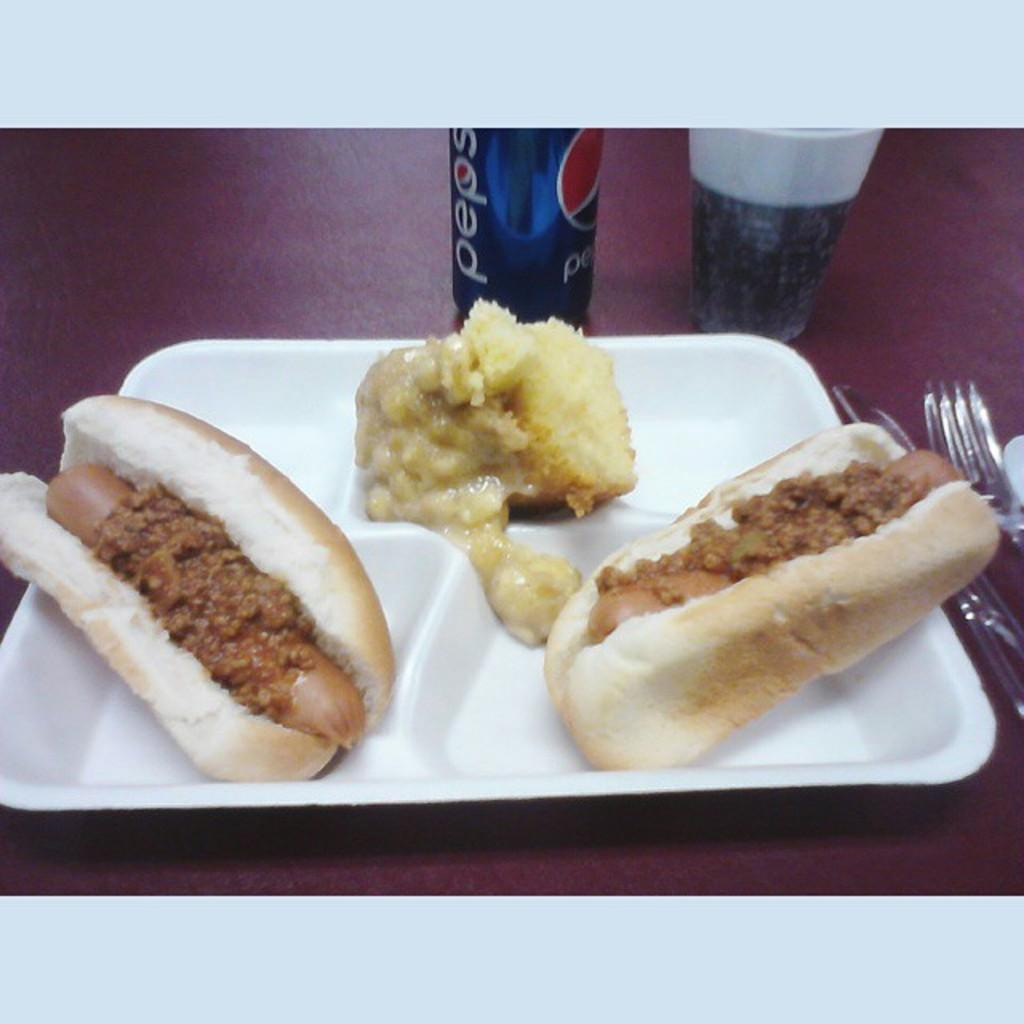What is on the plate that is visible in the image? There are hot dogs on the plate in the image. What other items can be seen in the image besides the plate? There is a tin, a glass, a knife, and a fork visible in the image. What might be used for cutting in the image? The knife in the image can be used for cutting. What might be used for eating in the image? The fork in the image can be used for eating. What type of religious symbol can be seen on the plate in the image? There is no religious symbol present on the plate or in the image. Is there a gun visible in the image? No, there is no gun present in the image. Can you see any explosive devices in the image? No, there are no explosive devices or bombs present in the image. 